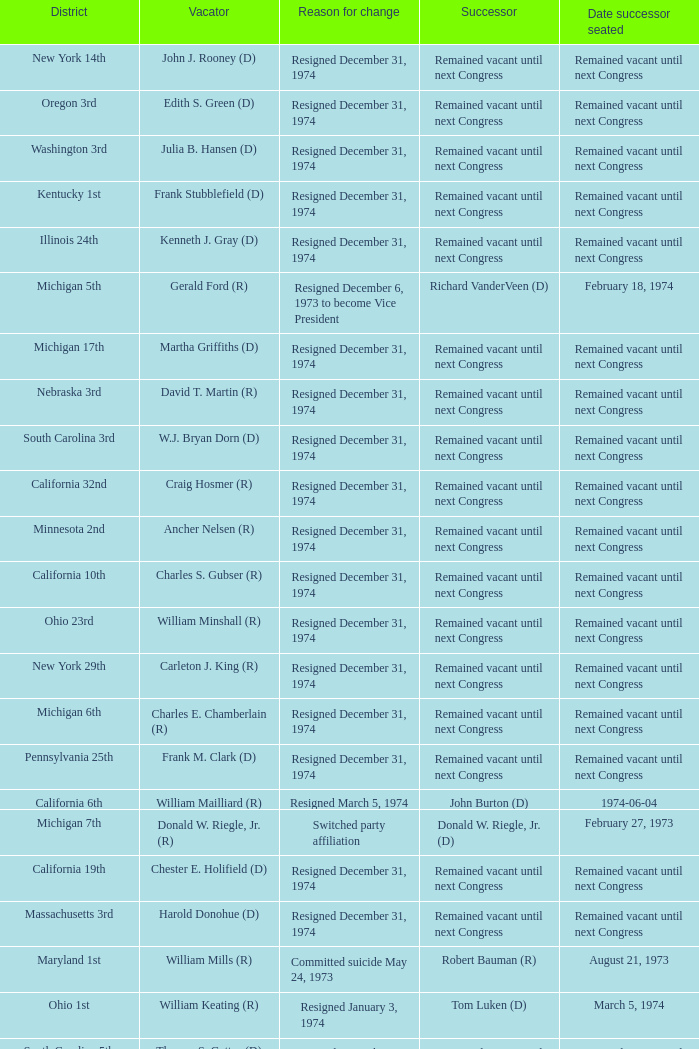Write the full table. {'header': ['District', 'Vacator', 'Reason for change', 'Successor', 'Date successor seated'], 'rows': [['New York 14th', 'John J. Rooney (D)', 'Resigned December 31, 1974', 'Remained vacant until next Congress', 'Remained vacant until next Congress'], ['Oregon 3rd', 'Edith S. Green (D)', 'Resigned December 31, 1974', 'Remained vacant until next Congress', 'Remained vacant until next Congress'], ['Washington 3rd', 'Julia B. Hansen (D)', 'Resigned December 31, 1974', 'Remained vacant until next Congress', 'Remained vacant until next Congress'], ['Kentucky 1st', 'Frank Stubblefield (D)', 'Resigned December 31, 1974', 'Remained vacant until next Congress', 'Remained vacant until next Congress'], ['Illinois 24th', 'Kenneth J. Gray (D)', 'Resigned December 31, 1974', 'Remained vacant until next Congress', 'Remained vacant until next Congress'], ['Michigan 5th', 'Gerald Ford (R)', 'Resigned December 6, 1973 to become Vice President', 'Richard VanderVeen (D)', 'February 18, 1974'], ['Michigan 17th', 'Martha Griffiths (D)', 'Resigned December 31, 1974', 'Remained vacant until next Congress', 'Remained vacant until next Congress'], ['Nebraska 3rd', 'David T. Martin (R)', 'Resigned December 31, 1974', 'Remained vacant until next Congress', 'Remained vacant until next Congress'], ['South Carolina 3rd', 'W.J. Bryan Dorn (D)', 'Resigned December 31, 1974', 'Remained vacant until next Congress', 'Remained vacant until next Congress'], ['California 32nd', 'Craig Hosmer (R)', 'Resigned December 31, 1974', 'Remained vacant until next Congress', 'Remained vacant until next Congress'], ['Minnesota 2nd', 'Ancher Nelsen (R)', 'Resigned December 31, 1974', 'Remained vacant until next Congress', 'Remained vacant until next Congress'], ['California 10th', 'Charles S. Gubser (R)', 'Resigned December 31, 1974', 'Remained vacant until next Congress', 'Remained vacant until next Congress'], ['Ohio 23rd', 'William Minshall (R)', 'Resigned December 31, 1974', 'Remained vacant until next Congress', 'Remained vacant until next Congress'], ['New York 29th', 'Carleton J. King (R)', 'Resigned December 31, 1974', 'Remained vacant until next Congress', 'Remained vacant until next Congress'], ['Michigan 6th', 'Charles E. Chamberlain (R)', 'Resigned December 31, 1974', 'Remained vacant until next Congress', 'Remained vacant until next Congress'], ['Pennsylvania 25th', 'Frank M. Clark (D)', 'Resigned December 31, 1974', 'Remained vacant until next Congress', 'Remained vacant until next Congress'], ['California 6th', 'William Mailliard (R)', 'Resigned March 5, 1974', 'John Burton (D)', '1974-06-04'], ['Michigan 7th', 'Donald W. Riegle, Jr. (R)', 'Switched party affiliation', 'Donald W. Riegle, Jr. (D)', 'February 27, 1973'], ['California 19th', 'Chester E. Holifield (D)', 'Resigned December 31, 1974', 'Remained vacant until next Congress', 'Remained vacant until next Congress'], ['Massachusetts 3rd', 'Harold Donohue (D)', 'Resigned December 31, 1974', 'Remained vacant until next Congress', 'Remained vacant until next Congress'], ['Maryland 1st', 'William Mills (R)', 'Committed suicide May 24, 1973', 'Robert Bauman (R)', 'August 21, 1973'], ['Ohio 1st', 'William Keating (R)', 'Resigned January 3, 1974', 'Tom Luken (D)', 'March 5, 1974'], ['South Carolina 5th', 'Thomas S. Gettys (D)', 'Resigned December 31, 1974', 'Remained vacant until next Congress', 'Remained vacant until next Congress'], ['New York 37th', 'Thaddeus J. Dulski (D)', 'Resigned December 31, 1974', 'Remained vacant until next Congress', 'Remained vacant until next Congress'], ['New Jersey 7th', 'William B. Widnall (R)', 'Resigned December 31, 1974', 'Remained vacant until next Congress', 'Remained vacant until next Congress'], ['California 13th', 'Charles Teague (R)', 'Died January 1, 1974', 'Robert Lagomarsino (R)', '1974-03-05'], ['California 34th', 'Richard T. Hanna (D)', 'Resigned December 31, 1974', 'Remained vacant until next Congress', 'Remained vacant until next Congress'], ['Texas 21st', 'O. C. Fisher (D)', 'Resigned December 31, 1974', 'Remained vacant until next Congress', 'Remained vacant until next Congress'], ['New York 15th', 'Hugh L. Carey (D)', 'Resigned December 31, 1974', 'Remained vacant until next Congress', 'Remained vacant until next Congress'], ['Pennsylvania 12th', 'John Saylor (R)', 'Died October 28, 1973', 'John Murtha (D)', 'February 5, 1974'], ['Wisconsin 3rd', 'Vernon W. Thomson (R)', 'Resigned December 31, 1974', 'Remained vacant until next Congress', 'Remained vacant until next Congress'], ['Minnesota 8th', 'John Blatnik (DFL)', 'Resigned December 31, 1974', 'Remained vacant until next Congress', 'Remained vacant until next Congress']]} Who was the vacator when the date successor seated was august 21, 1973? William Mills (R). 